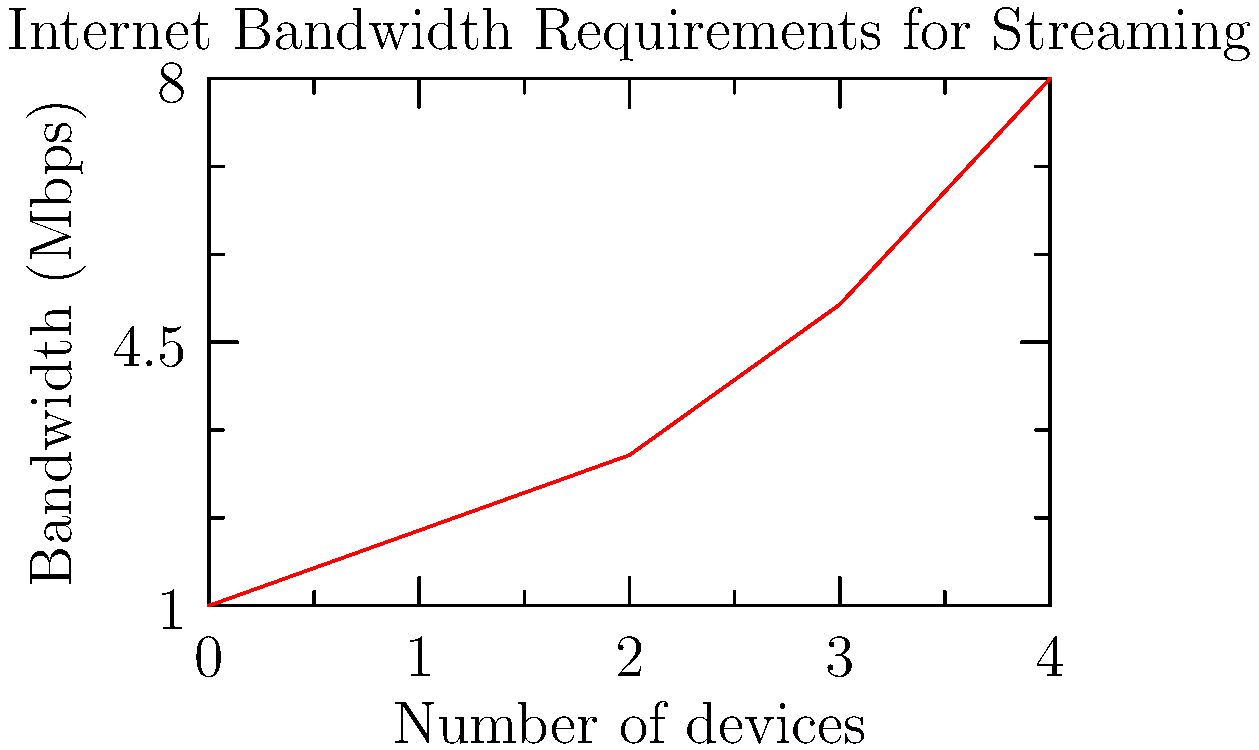Based on the line graph showing internet bandwidth requirements for streaming, how much additional bandwidth (in Mbps) would you need if you increase the number of streaming devices in your home from 2 to 4? To solve this problem, let's follow these steps:

1. Identify the bandwidth required for 2 devices:
   From the graph, we can see that 2 devices require 3 Mbps.

2. Identify the bandwidth required for 4 devices:
   The graph shows that 4 devices require 8 Mbps.

3. Calculate the difference in bandwidth:
   Additional bandwidth = Bandwidth for 4 devices - Bandwidth for 2 devices
   $8 \text{ Mbps} - 3 \text{ Mbps} = 5 \text{ Mbps}$

Therefore, you would need an additional 5 Mbps of bandwidth to increase from 2 to 4 streaming devices in your home.
Answer: 5 Mbps 